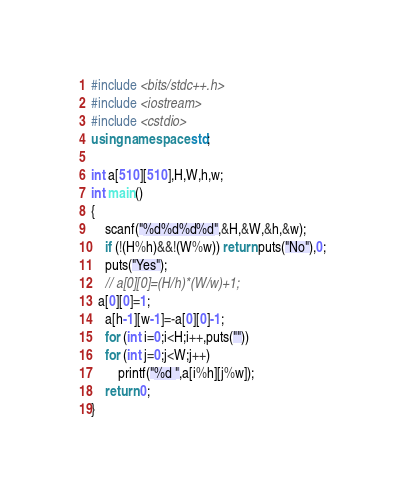<code> <loc_0><loc_0><loc_500><loc_500><_C++_>#include <bits/stdc++.h>
#include <iostream>
#include <cstdio>
using namespace std;

int a[510][510],H,W,h,w;
int main()
{
	scanf("%d%d%d%d",&H,&W,&h,&w);
	if (!(H%h)&&!(W%w)) return puts("No"),0;
	puts("Yes");
	// a[0][0]=(H/h)*(W/w)+1;
  a[0][0]=1;
	a[h-1][w-1]=-a[0][0]-1;
	for (int i=0;i<H;i++,puts(""))
	for (int j=0;j<W;j++)
		printf("%d ",a[i%h][j%w]);
	return 0;
}</code> 